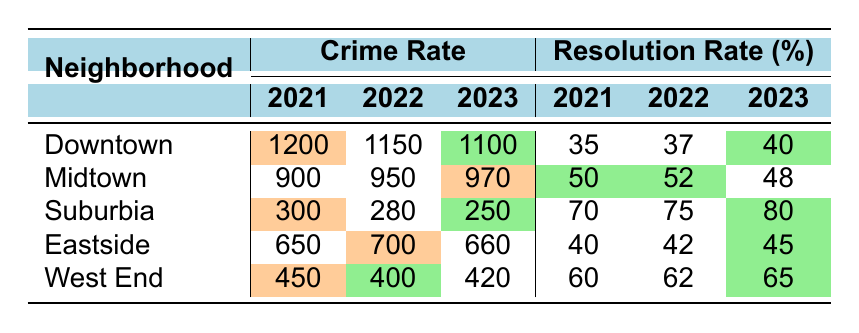What is the crime rate for Downtown in 2023? According to the table, the crime rate for Downtown in 2023 is listed as 1100.
Answer: 1100 Which neighborhood had the highest crime rate in 2021? The table shows that Downtown had the highest crime rate in 2021 at 1200 compared to other neighborhoods.
Answer: Downtown What was the resolution rate for Suburbia in 2022? The resolution rate for Suburbia in 2022 is indicated in the table as 75.
Answer: 75 How much did the crime rate decrease in Suburbia from 2021 to 2023? The crime rate in Suburbia was 300 in 2021 and decreased to 250 in 2023. The decrease is 300 - 250 = 50.
Answer: 50 Which neighborhood saw an increase in resolution rate from 2021 to 2023? Looking at the table, Suburbia's resolution rate increased from 70 in 2021 to 80 in 2023. Therefore, it saw an increase.
Answer: Yes What is the average crime rate across all neighborhoods in 2023? The crime rates in 2023 are 1100 (Downtown), 970 (Midtown), 250 (Suburbia), 660 (Eastside), and 420 (West End). Summing them gives 1100 + 970 + 250 + 660 + 420 = 3400. There are 5 neighborhoods, so the average is 3400/5 = 680.
Answer: 680 Which neighborhood had the lowest crime rate in 2023? Looking at the table, Suburbia has the lowest crime rate in 2023 at 250 compared to all other neighborhoods.
Answer: Suburbia What was the change in resolution rate for Midtown from 2021 to 2023? The resolution rate for Midtown was 50 in 2021 and decreased to 48 in 2023. The change is 50 - 48 = 2, indicating a decrease.
Answer: 2 Which neighborhood had the best resolution rate in 2023? By reviewing the resolution rates for 2023, Suburbia had the highest at 80, which is greater than all others.
Answer: Suburbia Did Eastside have a higher or lower resolution rate in 2023 compared to 2021? In 2021, Eastside's resolution rate was 40 and it increased to 45 in 2023, which means it had a higher rate in 2023.
Answer: Higher What is the crime rate trend in Downtown over the past three years? The crime rate in Downtown decreased from 1200 in 2021 to 1150 in 2022 and again to 1100 in 2023, indicating a downward trend.
Answer: Decreasing 